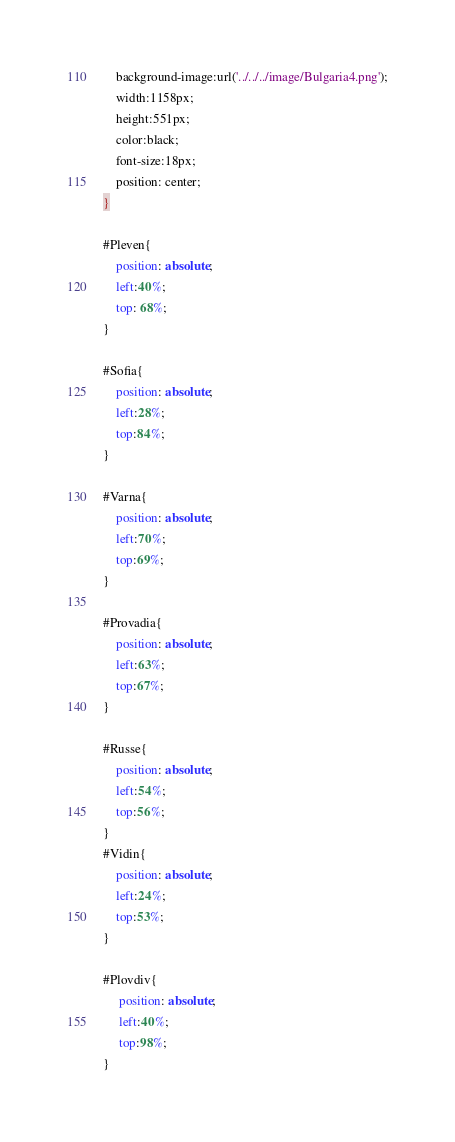Convert code to text. <code><loc_0><loc_0><loc_500><loc_500><_CSS_>    background-image:url('../../../image/Bulgaria4.png');
    width:1158px;
    height:551px;
    color:black;
    font-size:18px;
    position: center;
}

#Pleven{
    position: absolute;
    left:40%;
    top: 68%;
}

#Sofia{
    position: absolute;
    left:28%;
    top:84%;
}

#Varna{
    position: absolute;
    left:70%;
    top:69%;
}

#Provadia{
    position: absolute;
    left:63%;
    top:67%;
}

#Russe{
    position: absolute;
    left:54%;
    top:56%;
}
#Vidin{
    position: absolute;
    left:24%;
    top:53%;
}

#Plovdiv{
     position: absolute;
     left:40%;
     top:98%;
}
</code> 